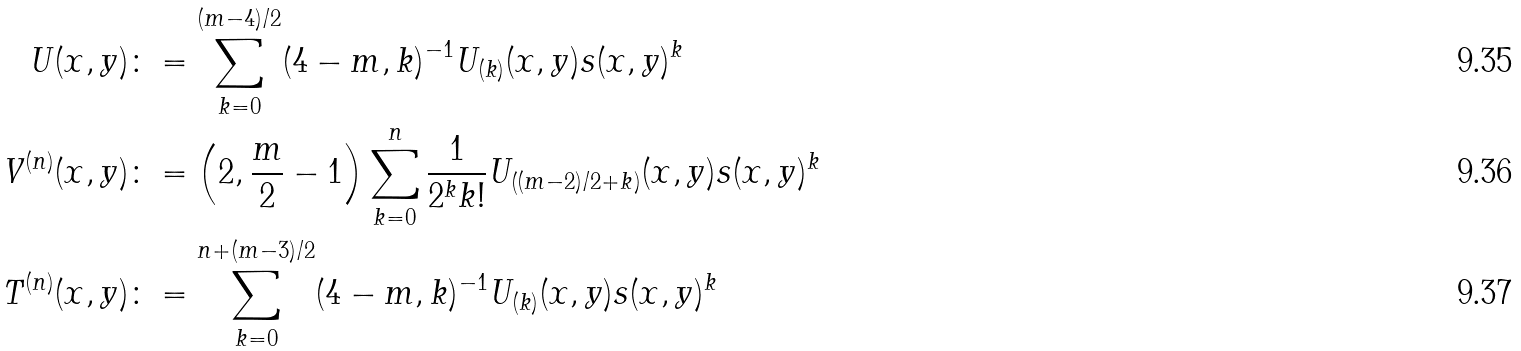<formula> <loc_0><loc_0><loc_500><loc_500>U ( x , y ) & \colon = \sum _ { k = 0 } ^ { ( m - 4 ) / 2 } ( 4 - m , k ) ^ { - 1 } U _ { ( k ) } ( x , y ) s ( x , y ) ^ { k } \\ V ^ { ( n ) } ( x , y ) & \colon = \left ( 2 , \frac { m } { 2 } - 1 \right ) \sum _ { k = 0 } ^ { n } \frac { 1 } { 2 ^ { k } k ! } U _ { \left ( ( m - 2 ) / 2 + k \right ) } ( x , y ) s ( x , y ) ^ { k } \\ T ^ { ( n ) } ( x , y ) & \colon = \sum _ { k = 0 } ^ { n + ( m - 3 ) / 2 } ( 4 - m , k ) ^ { - 1 } U _ { ( k ) } ( x , y ) s ( x , y ) ^ { k }</formula> 